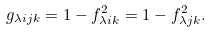<formula> <loc_0><loc_0><loc_500><loc_500>g _ { \lambda i j k } = 1 - f _ { \lambda i k } ^ { 2 } = 1 - f _ { \lambda j k } ^ { 2 } .</formula> 